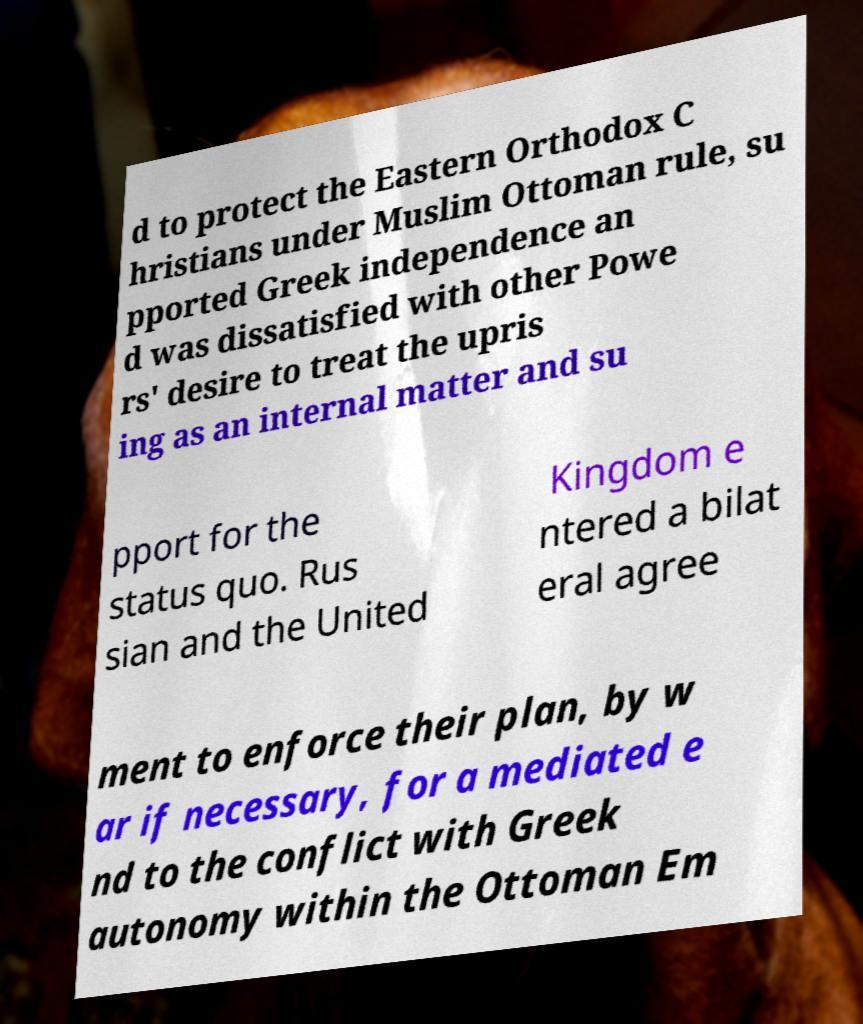Can you read and provide the text displayed in the image?This photo seems to have some interesting text. Can you extract and type it out for me? d to protect the Eastern Orthodox C hristians under Muslim Ottoman rule, su pported Greek independence an d was dissatisfied with other Powe rs' desire to treat the upris ing as an internal matter and su pport for the status quo. Rus sian and the United Kingdom e ntered a bilat eral agree ment to enforce their plan, by w ar if necessary, for a mediated e nd to the conflict with Greek autonomy within the Ottoman Em 